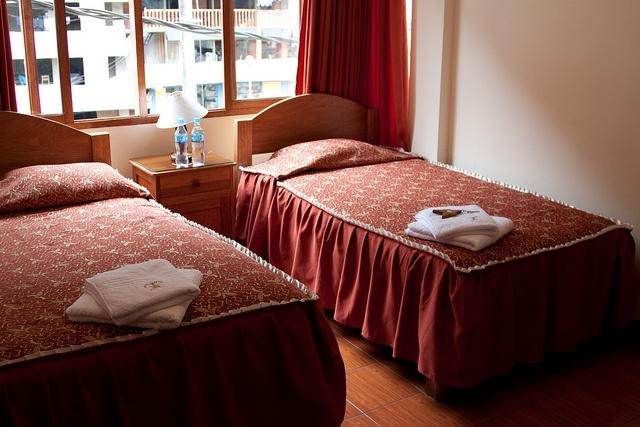Describe the objects in this image and their specific colors. I can see bed in brown, black, maroon, and lightpink tones, bed in brown, black, maroon, and lightpink tones, bottle in brown, lightgray, darkgray, gray, and tan tones, and bottle in brown, tan, lightgray, and darkgray tones in this image. 